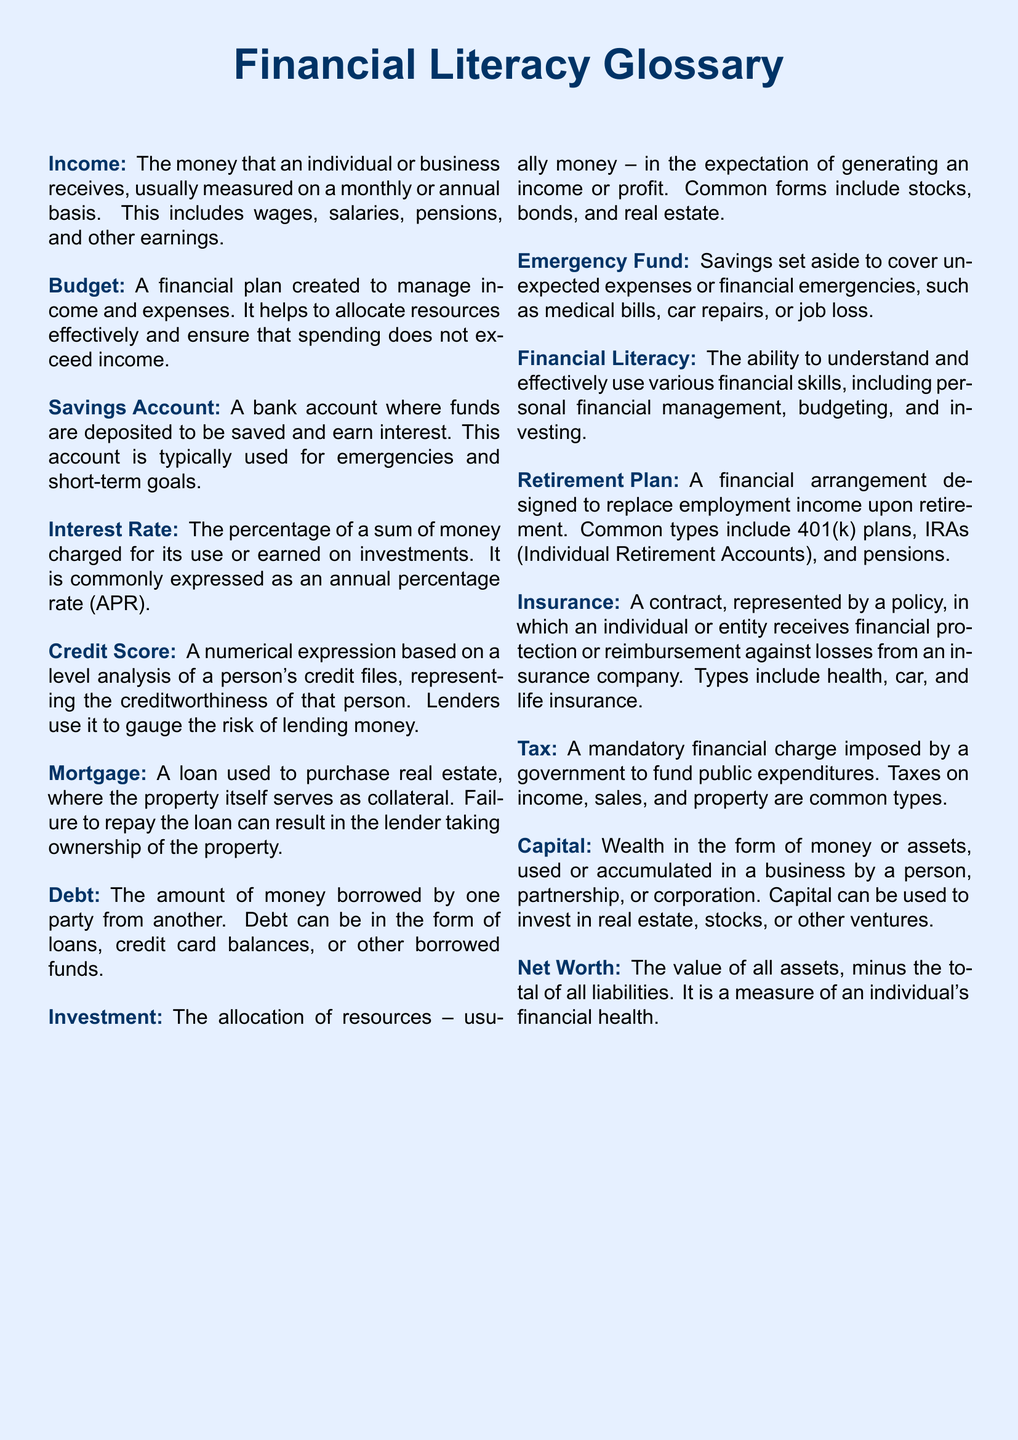What is a Savings Account? A Savings Account is a bank account where funds are deposited to be saved and earn interest.
Answer: A bank account for saving What does Debt refer to? Debt refers to the amount of money borrowed by one party from another, including loans and credit card balances.
Answer: Borrowed money What is the purpose of an Emergency Fund? An Emergency Fund is savings set aside to cover unexpected expenses or financial emergencies.
Answer: Cover unexpected expenses How is Credit Score defined? A Credit Score is a numerical expression analyzing a person's credit files, representing their creditworthiness.
Answer: Numerical expression of creditworthiness What type of financial arrangement is a Retirement Plan? A Retirement Plan is a financial arrangement designed to replace employment income upon retirement.
Answer: Income replacement upon retirement What does the term Capital refer to? Capital refers to wealth in the form of money or assets used or accumulated in a business.
Answer: Wealth in money or assets What kind of financial charge is a Tax? A Tax is a mandatory financial charge imposed by a government to fund public expenditures.
Answer: Mandatory financial charge How can Financial Literacy be defined? Financial Literacy is the ability to understand and effectively use various financial skills, including budgeting and investing.
Answer: Understanding financial skills 